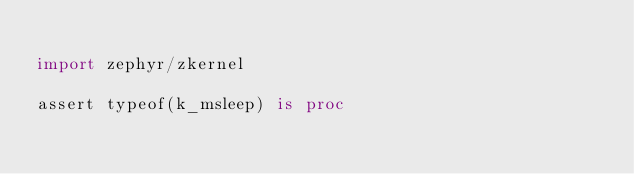<code> <loc_0><loc_0><loc_500><loc_500><_Nim_>
import zephyr/zkernel

assert typeof(k_msleep) is proc
</code> 